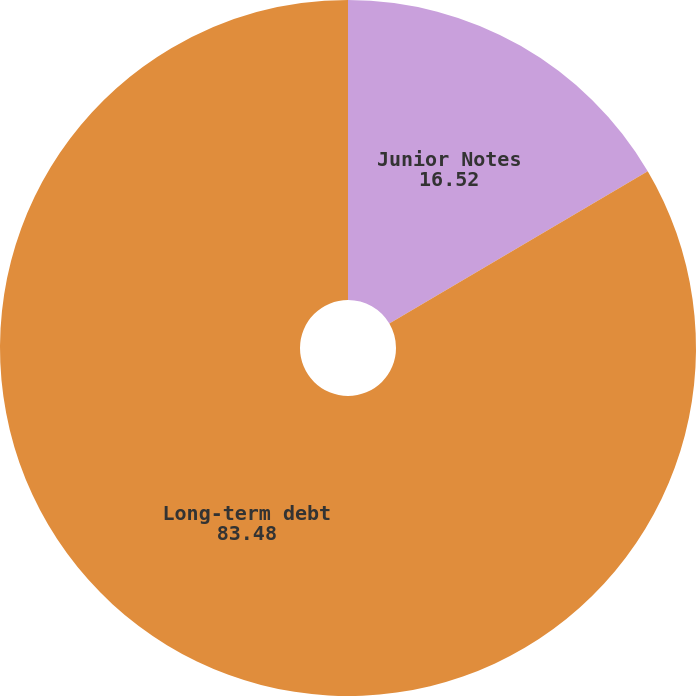Convert chart to OTSL. <chart><loc_0><loc_0><loc_500><loc_500><pie_chart><fcel>Junior Notes<fcel>Long-term debt<nl><fcel>16.52%<fcel>83.48%<nl></chart> 